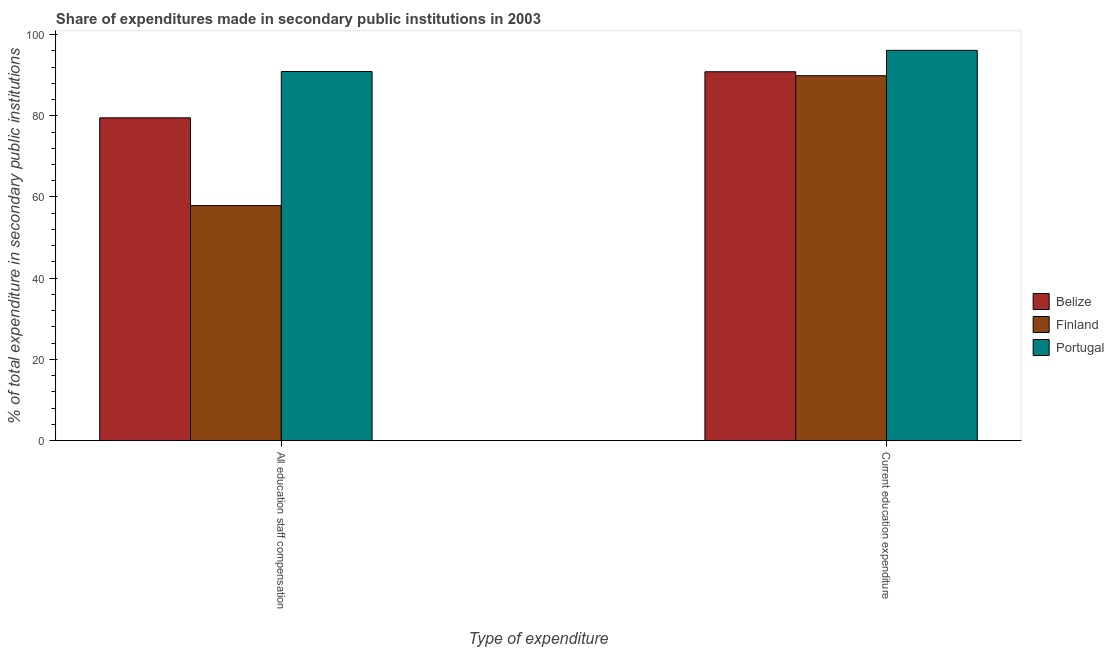How many bars are there on the 2nd tick from the right?
Provide a succinct answer. 3. What is the label of the 2nd group of bars from the left?
Your answer should be very brief. Current education expenditure. What is the expenditure in staff compensation in Finland?
Ensure brevity in your answer.  57.87. Across all countries, what is the maximum expenditure in staff compensation?
Your answer should be compact. 90.9. Across all countries, what is the minimum expenditure in staff compensation?
Your response must be concise. 57.87. In which country was the expenditure in staff compensation maximum?
Provide a short and direct response. Portugal. In which country was the expenditure in education minimum?
Offer a terse response. Finland. What is the total expenditure in education in the graph?
Keep it short and to the point. 276.83. What is the difference between the expenditure in education in Belize and that in Finland?
Your answer should be very brief. 0.98. What is the difference between the expenditure in education in Portugal and the expenditure in staff compensation in Finland?
Your answer should be very brief. 38.24. What is the average expenditure in staff compensation per country?
Provide a succinct answer. 76.09. What is the difference between the expenditure in education and expenditure in staff compensation in Belize?
Give a very brief answer. 11.35. In how many countries, is the expenditure in education greater than 64 %?
Your response must be concise. 3. What is the ratio of the expenditure in staff compensation in Portugal to that in Finland?
Offer a very short reply. 1.57. In how many countries, is the expenditure in staff compensation greater than the average expenditure in staff compensation taken over all countries?
Your response must be concise. 2. What does the 2nd bar from the left in Current education expenditure represents?
Make the answer very short. Finland. What does the 1st bar from the right in Current education expenditure represents?
Keep it short and to the point. Portugal. How many bars are there?
Provide a succinct answer. 6. What is the difference between two consecutive major ticks on the Y-axis?
Offer a terse response. 20. Does the graph contain grids?
Offer a very short reply. No. Where does the legend appear in the graph?
Ensure brevity in your answer.  Center right. How many legend labels are there?
Ensure brevity in your answer.  3. How are the legend labels stacked?
Provide a succinct answer. Vertical. What is the title of the graph?
Offer a terse response. Share of expenditures made in secondary public institutions in 2003. Does "Djibouti" appear as one of the legend labels in the graph?
Give a very brief answer. No. What is the label or title of the X-axis?
Make the answer very short. Type of expenditure. What is the label or title of the Y-axis?
Your response must be concise. % of total expenditure in secondary public institutions. What is the % of total expenditure in secondary public institutions in Belize in All education staff compensation?
Make the answer very short. 79.49. What is the % of total expenditure in secondary public institutions in Finland in All education staff compensation?
Offer a very short reply. 57.87. What is the % of total expenditure in secondary public institutions of Portugal in All education staff compensation?
Your answer should be very brief. 90.9. What is the % of total expenditure in secondary public institutions of Belize in Current education expenditure?
Provide a succinct answer. 90.84. What is the % of total expenditure in secondary public institutions of Finland in Current education expenditure?
Give a very brief answer. 89.87. What is the % of total expenditure in secondary public institutions of Portugal in Current education expenditure?
Give a very brief answer. 96.12. Across all Type of expenditure, what is the maximum % of total expenditure in secondary public institutions of Belize?
Your answer should be very brief. 90.84. Across all Type of expenditure, what is the maximum % of total expenditure in secondary public institutions in Finland?
Your answer should be compact. 89.87. Across all Type of expenditure, what is the maximum % of total expenditure in secondary public institutions of Portugal?
Your response must be concise. 96.12. Across all Type of expenditure, what is the minimum % of total expenditure in secondary public institutions of Belize?
Provide a succinct answer. 79.49. Across all Type of expenditure, what is the minimum % of total expenditure in secondary public institutions in Finland?
Keep it short and to the point. 57.87. Across all Type of expenditure, what is the minimum % of total expenditure in secondary public institutions in Portugal?
Ensure brevity in your answer.  90.9. What is the total % of total expenditure in secondary public institutions in Belize in the graph?
Your response must be concise. 170.34. What is the total % of total expenditure in secondary public institutions of Finland in the graph?
Give a very brief answer. 147.74. What is the total % of total expenditure in secondary public institutions of Portugal in the graph?
Keep it short and to the point. 187.02. What is the difference between the % of total expenditure in secondary public institutions of Belize in All education staff compensation and that in Current education expenditure?
Your response must be concise. -11.35. What is the difference between the % of total expenditure in secondary public institutions in Finland in All education staff compensation and that in Current education expenditure?
Your answer should be very brief. -31.99. What is the difference between the % of total expenditure in secondary public institutions of Portugal in All education staff compensation and that in Current education expenditure?
Your answer should be very brief. -5.22. What is the difference between the % of total expenditure in secondary public institutions in Belize in All education staff compensation and the % of total expenditure in secondary public institutions in Finland in Current education expenditure?
Provide a succinct answer. -10.37. What is the difference between the % of total expenditure in secondary public institutions of Belize in All education staff compensation and the % of total expenditure in secondary public institutions of Portugal in Current education expenditure?
Keep it short and to the point. -16.62. What is the difference between the % of total expenditure in secondary public institutions in Finland in All education staff compensation and the % of total expenditure in secondary public institutions in Portugal in Current education expenditure?
Your response must be concise. -38.24. What is the average % of total expenditure in secondary public institutions in Belize per Type of expenditure?
Offer a terse response. 85.17. What is the average % of total expenditure in secondary public institutions in Finland per Type of expenditure?
Provide a short and direct response. 73.87. What is the average % of total expenditure in secondary public institutions of Portugal per Type of expenditure?
Make the answer very short. 93.51. What is the difference between the % of total expenditure in secondary public institutions of Belize and % of total expenditure in secondary public institutions of Finland in All education staff compensation?
Your answer should be compact. 21.62. What is the difference between the % of total expenditure in secondary public institutions in Belize and % of total expenditure in secondary public institutions in Portugal in All education staff compensation?
Ensure brevity in your answer.  -11.4. What is the difference between the % of total expenditure in secondary public institutions in Finland and % of total expenditure in secondary public institutions in Portugal in All education staff compensation?
Keep it short and to the point. -33.02. What is the difference between the % of total expenditure in secondary public institutions in Belize and % of total expenditure in secondary public institutions in Finland in Current education expenditure?
Keep it short and to the point. 0.98. What is the difference between the % of total expenditure in secondary public institutions in Belize and % of total expenditure in secondary public institutions in Portugal in Current education expenditure?
Provide a succinct answer. -5.28. What is the difference between the % of total expenditure in secondary public institutions in Finland and % of total expenditure in secondary public institutions in Portugal in Current education expenditure?
Offer a terse response. -6.25. What is the ratio of the % of total expenditure in secondary public institutions of Belize in All education staff compensation to that in Current education expenditure?
Provide a succinct answer. 0.88. What is the ratio of the % of total expenditure in secondary public institutions in Finland in All education staff compensation to that in Current education expenditure?
Provide a succinct answer. 0.64. What is the ratio of the % of total expenditure in secondary public institutions in Portugal in All education staff compensation to that in Current education expenditure?
Provide a short and direct response. 0.95. What is the difference between the highest and the second highest % of total expenditure in secondary public institutions of Belize?
Provide a short and direct response. 11.35. What is the difference between the highest and the second highest % of total expenditure in secondary public institutions in Finland?
Give a very brief answer. 31.99. What is the difference between the highest and the second highest % of total expenditure in secondary public institutions of Portugal?
Ensure brevity in your answer.  5.22. What is the difference between the highest and the lowest % of total expenditure in secondary public institutions of Belize?
Your answer should be compact. 11.35. What is the difference between the highest and the lowest % of total expenditure in secondary public institutions of Finland?
Ensure brevity in your answer.  31.99. What is the difference between the highest and the lowest % of total expenditure in secondary public institutions of Portugal?
Give a very brief answer. 5.22. 